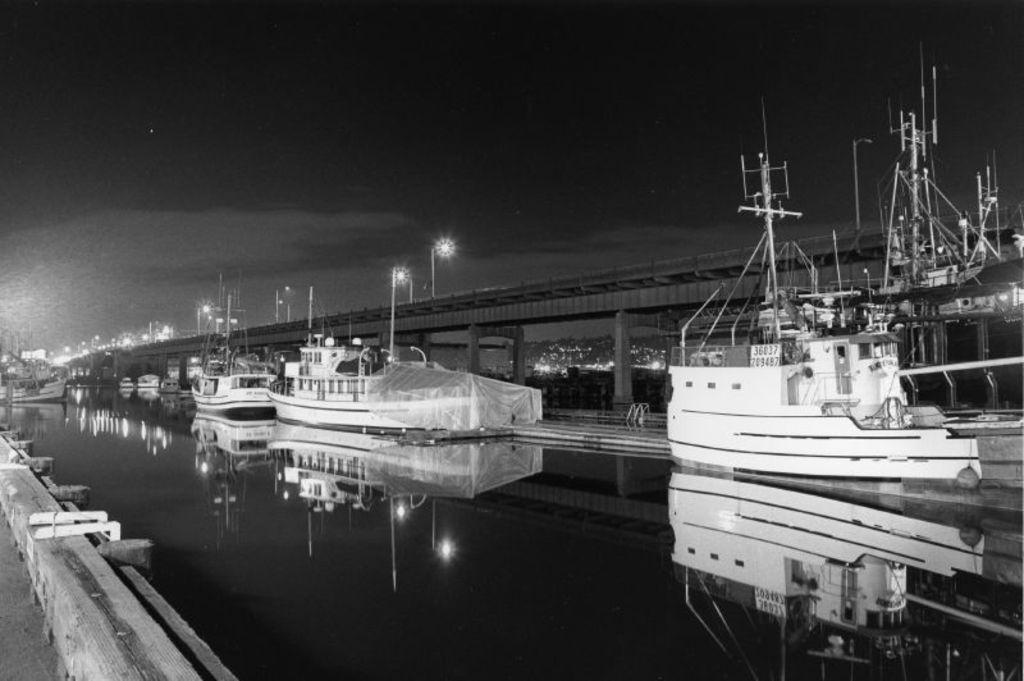Could you give a brief overview of what you see in this image? This is a black and white image. In this image there is water. There are boats on the water. Near to that there is a bridge with light poles and pillars. In the background there is sky. 